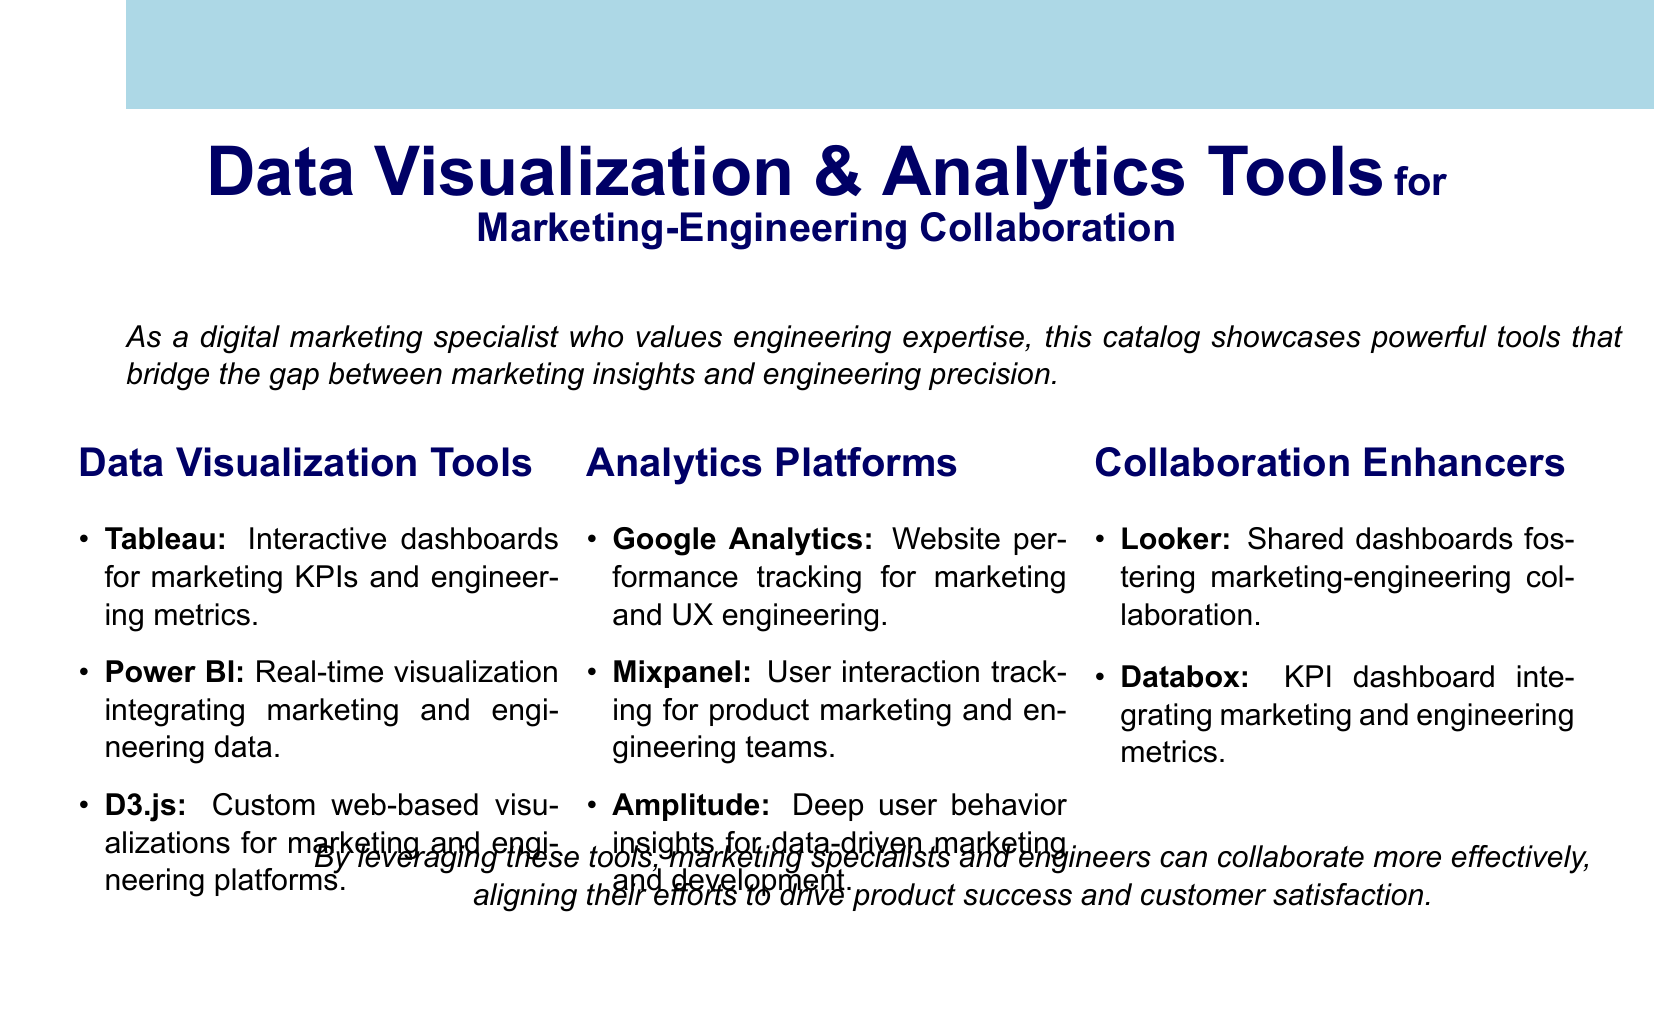what is the title of the document? The title is prominently displayed at the top of the document, showcasing the focus on data visualization and analytics tools.
Answer: Data Visualization & Analytics Tools for Marketing-Engineering Collaboration how many data visualization tools are listed? The document includes a section specifically dedicated to data visualization tools, which is identifiable by its item count.
Answer: 3 name one collaboration enhancer mentioned in the document. The collaboration enhancers category lists tools designed to support the collaborative efforts of marketing and engineering teams.
Answer: Looker what type of platform is Mixpanel? The document describes various analytics platforms, specifying what they are used for in the context of marketing and engineering.
Answer: User interaction tracking which tool provides real-time visualization? The document highlights specific tools within the analytics platforms that emphasize integration and real-time tracking capabilities.
Answer: Power BI what is the primary function of Google Analytics? The document outlines the functionality of each analytics platform, clarifying their application within marketing and engineering.
Answer: Website performance tracking how many categories of tools are listed in the document? The document presents tools organized into distinct categories, each serving different purposes for marketing and engineering.
Answer: 3 which visualization tool allows for custom web-based visualizations? The document details features of data visualization tools, identifying specific tools by their customization capabilities.
Answer: D3.js name the analytics platform focused on deep user behavior insights. The document provides names of analytics platforms and their specific focus, particularly relevant to user behavior.
Answer: Amplitude 